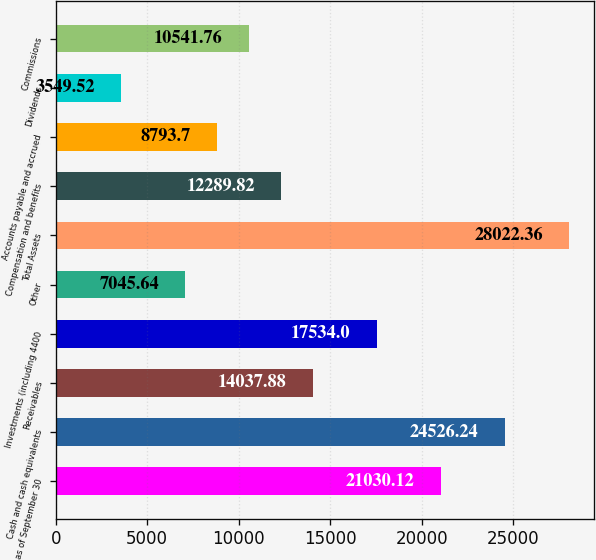<chart> <loc_0><loc_0><loc_500><loc_500><bar_chart><fcel>as of September 30<fcel>Cash and cash equivalents<fcel>Receivables<fcel>Investments (including 4400<fcel>Other<fcel>Total Assets<fcel>Compensation and benefits<fcel>Accounts payable and accrued<fcel>Dividends<fcel>Commissions<nl><fcel>21030.1<fcel>24526.2<fcel>14037.9<fcel>17534<fcel>7045.64<fcel>28022.4<fcel>12289.8<fcel>8793.7<fcel>3549.52<fcel>10541.8<nl></chart> 